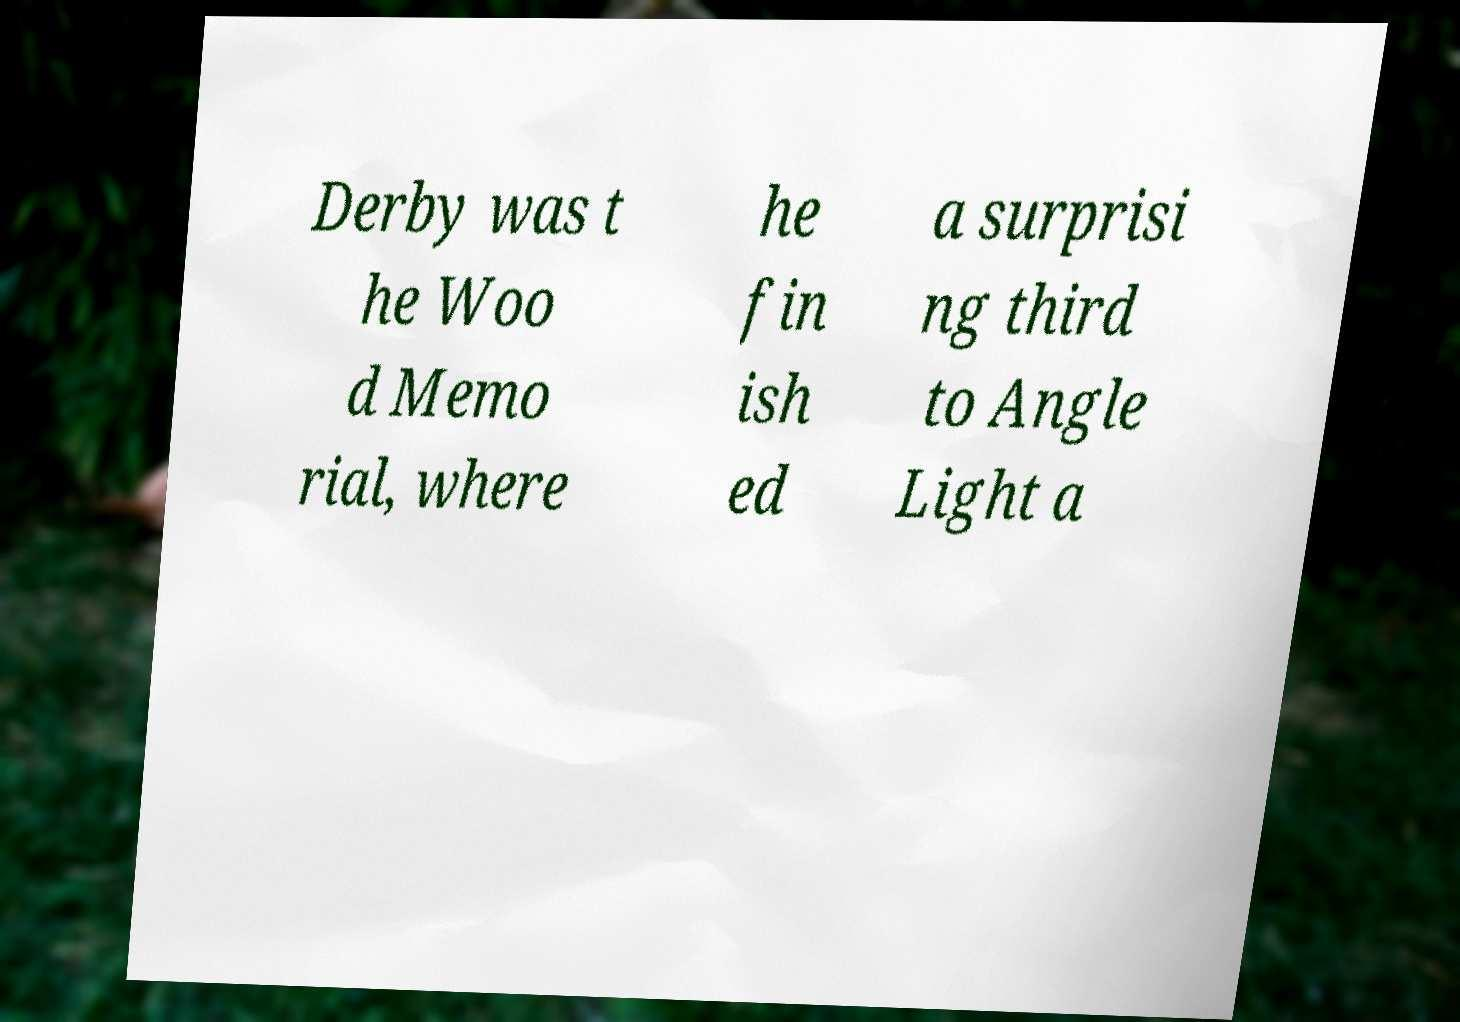Could you extract and type out the text from this image? Derby was t he Woo d Memo rial, where he fin ish ed a surprisi ng third to Angle Light a 